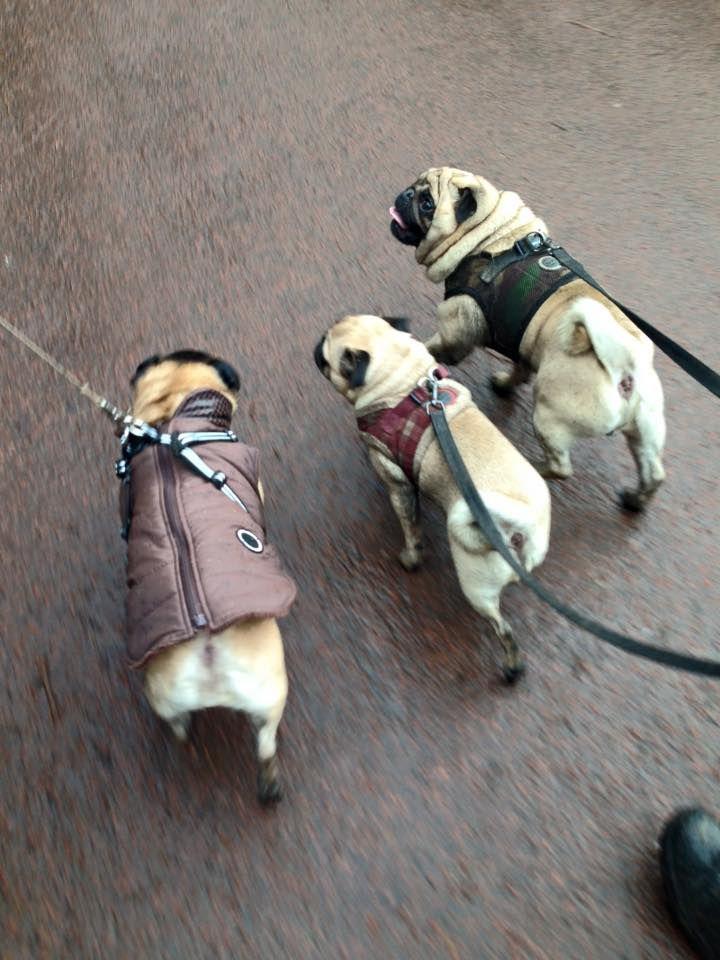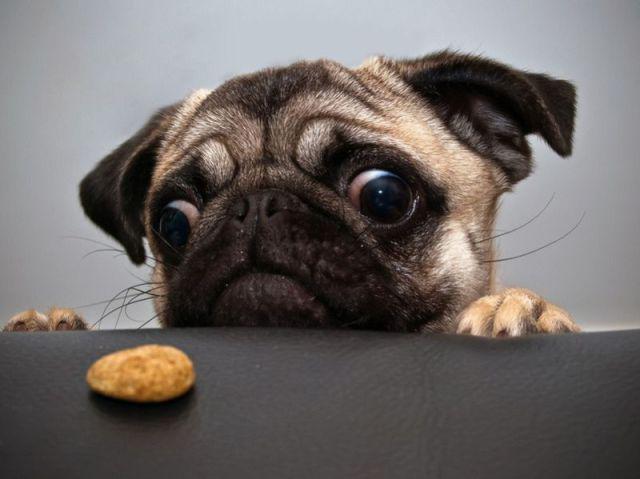The first image is the image on the left, the second image is the image on the right. For the images displayed, is the sentence "An image shows a pug dog wearing some type of band over its head." factually correct? Answer yes or no. No. The first image is the image on the left, the second image is the image on the right. Assess this claim about the two images: "Thre are two dogs in total.". Correct or not? Answer yes or no. No. 